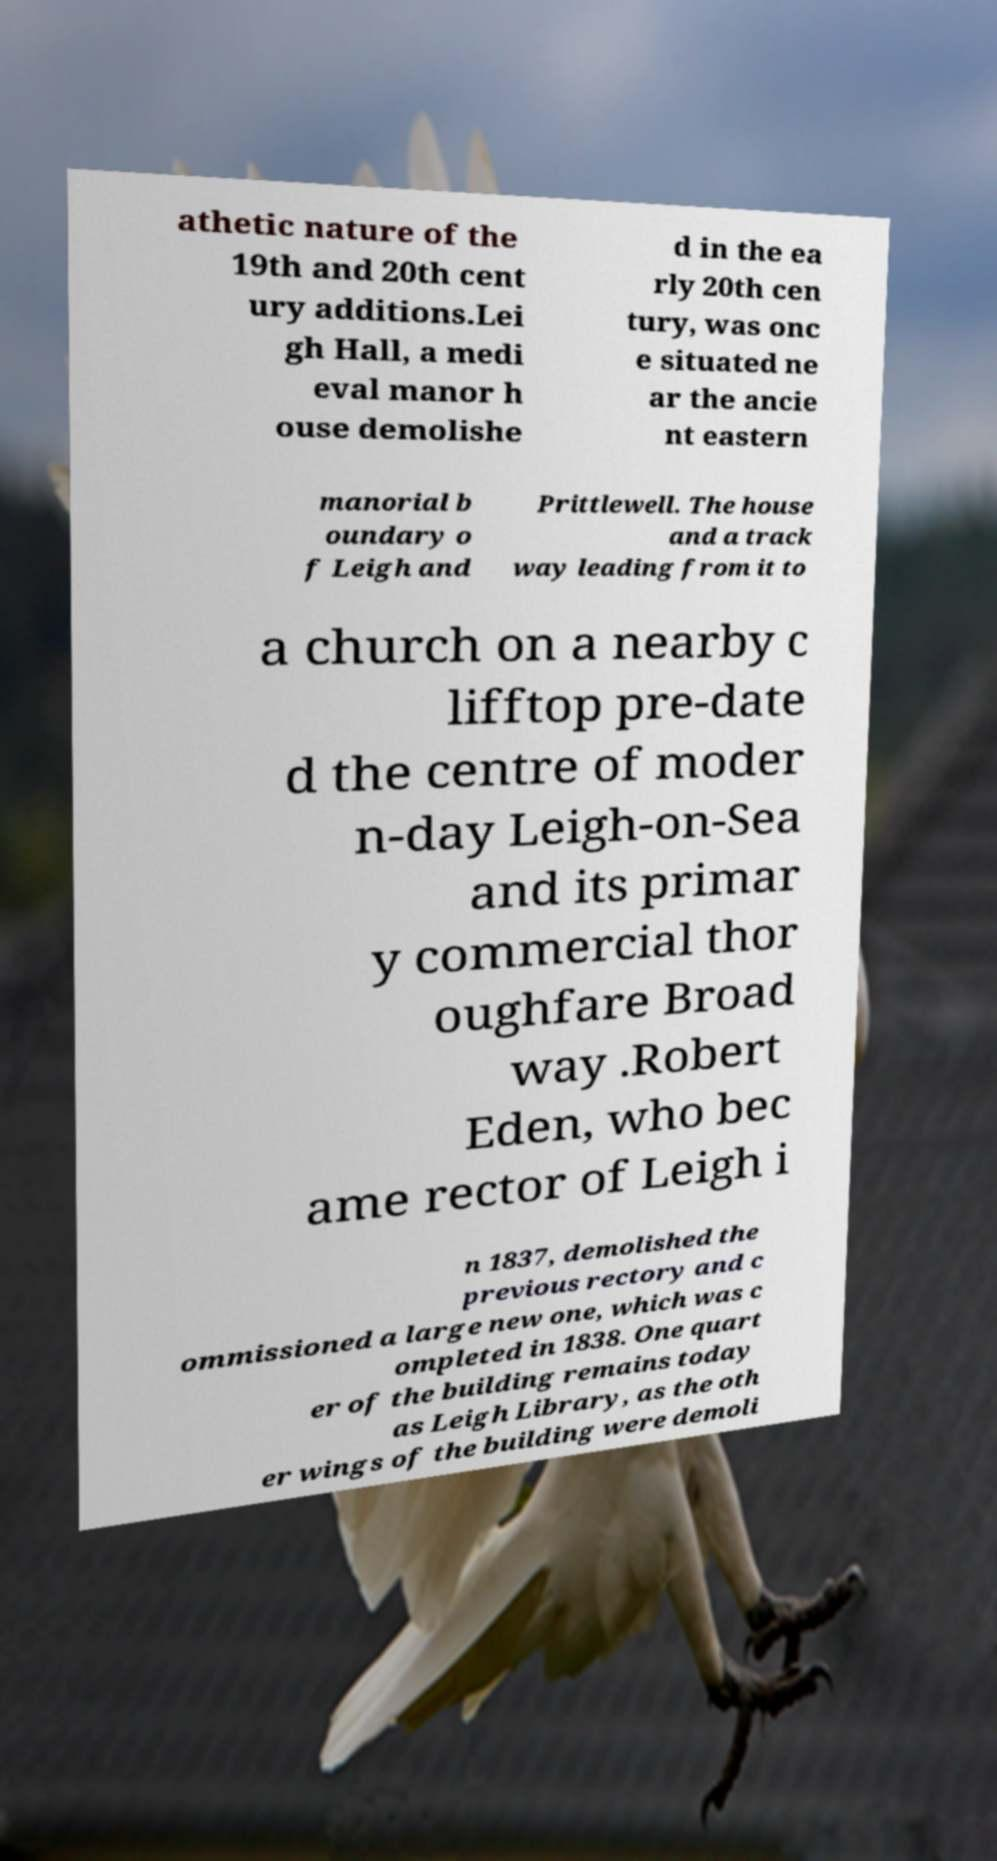Could you assist in decoding the text presented in this image and type it out clearly? athetic nature of the 19th and 20th cent ury additions.Lei gh Hall, a medi eval manor h ouse demolishe d in the ea rly 20th cen tury, was onc e situated ne ar the ancie nt eastern manorial b oundary o f Leigh and Prittlewell. The house and a track way leading from it to a church on a nearby c lifftop pre-date d the centre of moder n-day Leigh-on-Sea and its primar y commercial thor oughfare Broad way .Robert Eden, who bec ame rector of Leigh i n 1837, demolished the previous rectory and c ommissioned a large new one, which was c ompleted in 1838. One quart er of the building remains today as Leigh Library, as the oth er wings of the building were demoli 